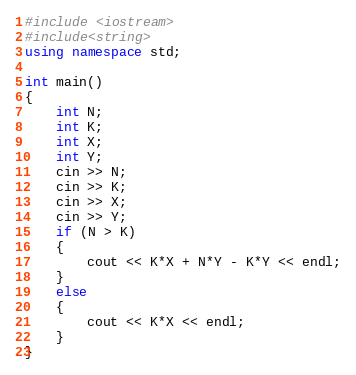<code> <loc_0><loc_0><loc_500><loc_500><_C++_>#include <iostream>
#include<string>
using namespace std;

int main()
{
	int N;
	int K;
	int X;
	int Y;
	cin >> N;
	cin >> K;
	cin >> X;
	cin >> Y;
	if (N > K)
	{
		cout << K*X + N*Y - K*Y << endl;
	}
	else
	{
		cout << K*X << endl;
	}
}</code> 